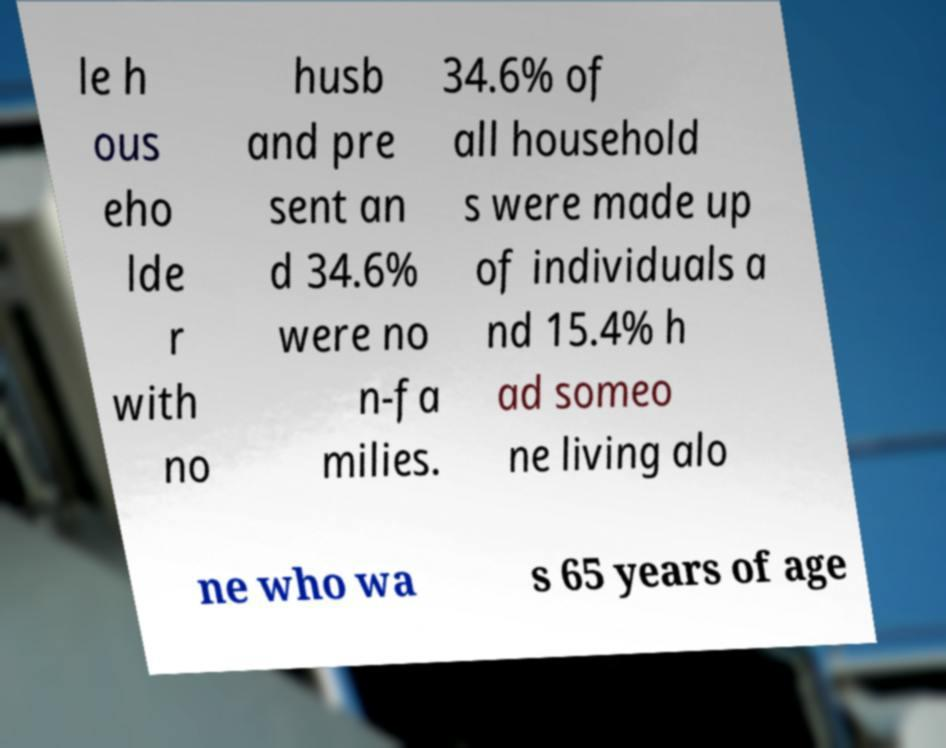Is there anything else notable about the presentation or layout of this document? The document is presented with clear headings and subheadings, likely to facilitate easy reading and comprehension of the data. The use of bold text emphasizes key figures. However, the image captures only part of the document, leaving the full context and comprehensiveness somewhat unknown. Additionally, the blurriness and the angle at which the photo was taken obscure some details. 